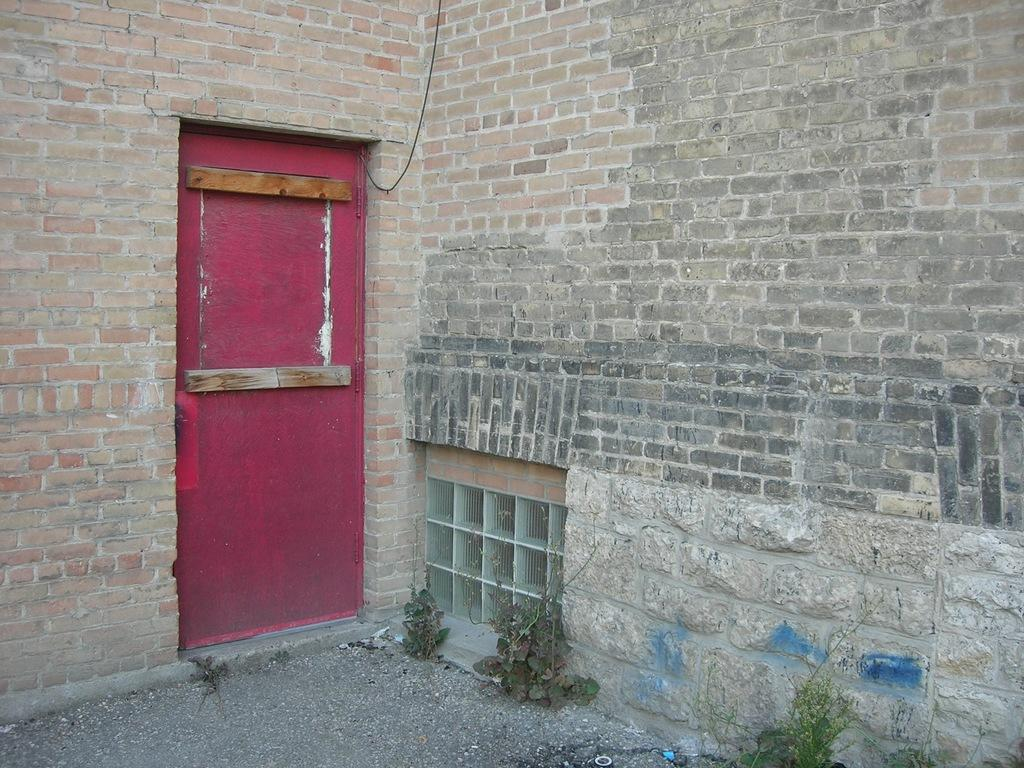What type of wall is visible in the image? There is a brick wall in the image. What is the color of the door in the image? The door in the image is pink. Where is the door located in relation to the brick wall? The door is located between sections of the brick wall. How many eggs are being laid by the duck in the image? There is no duck or eggs present in the image. What type of performance is taking place on the stage in the image? There is no stage present in the image. 